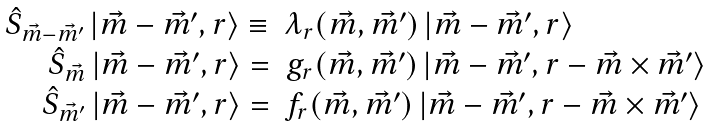<formula> <loc_0><loc_0><loc_500><loc_500>\begin{array} { r l } \hat { S } _ { { \vec { m } } - { \vec { m } } ^ { \prime } } \, | { \vec { m } } - { \vec { m } } ^ { \prime } , r \rangle \equiv & \lambda _ { r } ( { \vec { m } } , { \vec { m } } ^ { \prime } ) \, | { \vec { m } } - { \vec { m } } ^ { \prime } , r \rangle \\ \hat { S } _ { \vec { m } } \, | { \vec { m } } - { \vec { m } } ^ { \prime } , r \rangle = & g _ { r } ( { \vec { m } } , { \vec { m } } ^ { \prime } ) \, | { \vec { m } } - { \vec { m } } ^ { \prime } , r - { \vec { m } } \times { \vec { m } } ^ { \prime } \rangle \\ \hat { S } _ { { \vec { m } } ^ { \prime } } \, | { \vec { m } } - { \vec { m } } ^ { \prime } , r \rangle = & f _ { r } ( { \vec { m } } , { \vec { m } } ^ { \prime } ) \, | { \vec { m } } - { \vec { m } } ^ { \prime } , r - { \vec { m } } \times { \vec { m } } ^ { \prime } \rangle \\ \end{array}</formula> 